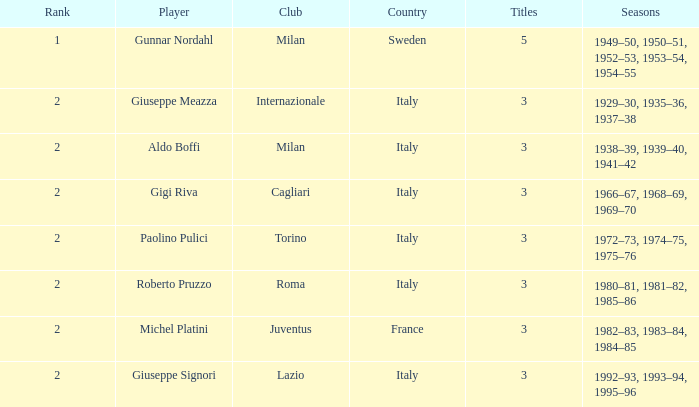How many rankings are linked with giuseppe meazza possessing more than 3 titles? 0.0. 